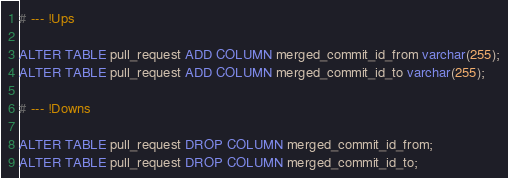<code> <loc_0><loc_0><loc_500><loc_500><_SQL_># --- !Ups

ALTER TABLE pull_request ADD COLUMN merged_commit_id_from varchar(255);
ALTER TABLE pull_request ADD COLUMN merged_commit_id_to varchar(255);

# --- !Downs

ALTER TABLE pull_request DROP COLUMN merged_commit_id_from;
ALTER TABLE pull_request DROP COLUMN merged_commit_id_to;
</code> 